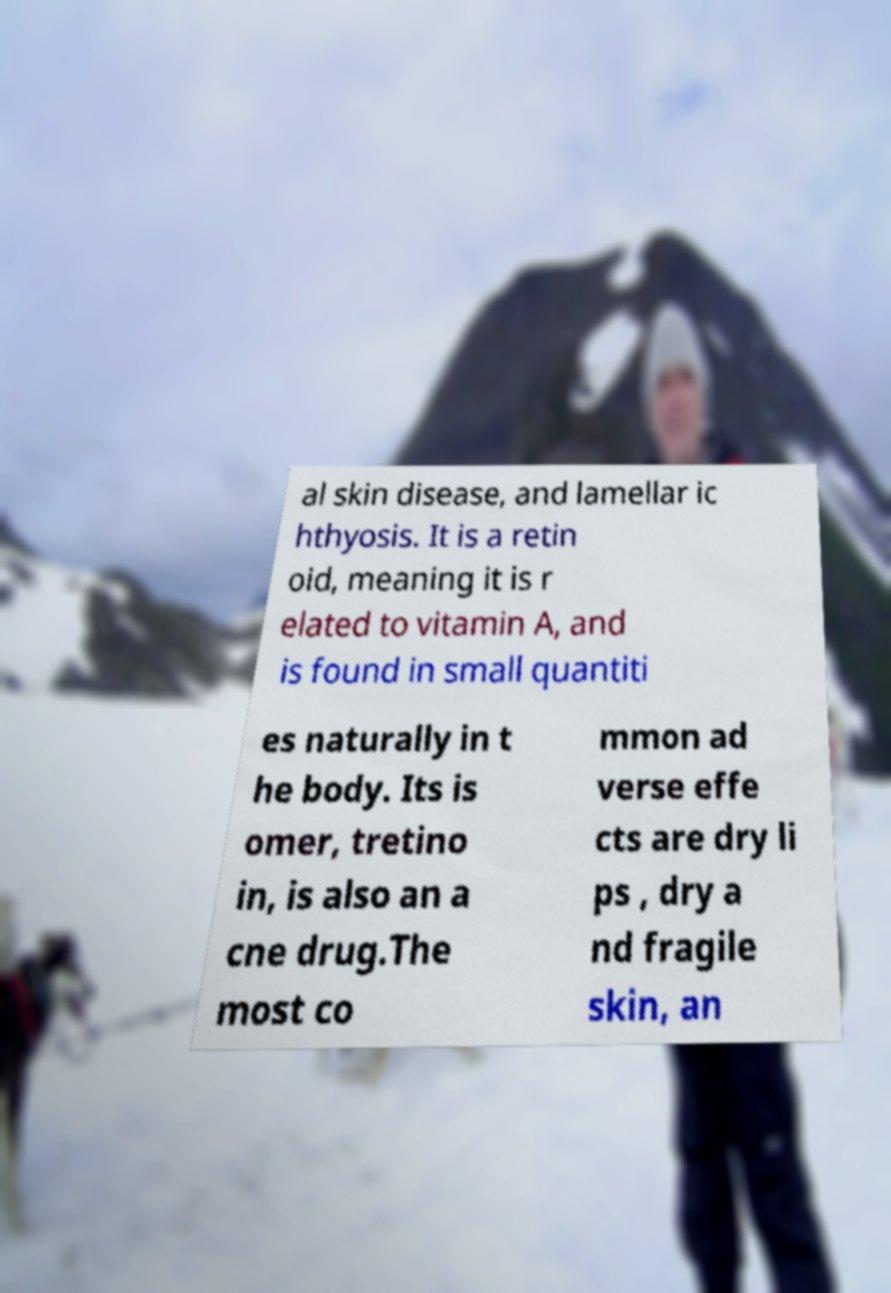For documentation purposes, I need the text within this image transcribed. Could you provide that? al skin disease, and lamellar ic hthyosis. It is a retin oid, meaning it is r elated to vitamin A, and is found in small quantiti es naturally in t he body. Its is omer, tretino in, is also an a cne drug.The most co mmon ad verse effe cts are dry li ps , dry a nd fragile skin, an 